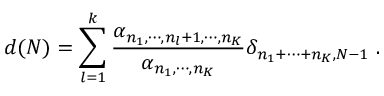<formula> <loc_0><loc_0><loc_500><loc_500>d ( N ) = \sum _ { l = 1 } ^ { k } \frac { \alpha _ { n _ { 1 } , \cdots , n _ { l } + 1 , \cdots , n _ { K } } } { \alpha _ { n _ { 1 } , \cdots , n _ { K } } } \delta _ { n _ { 1 } + \cdots + n _ { K } , N - 1 } \ .</formula> 